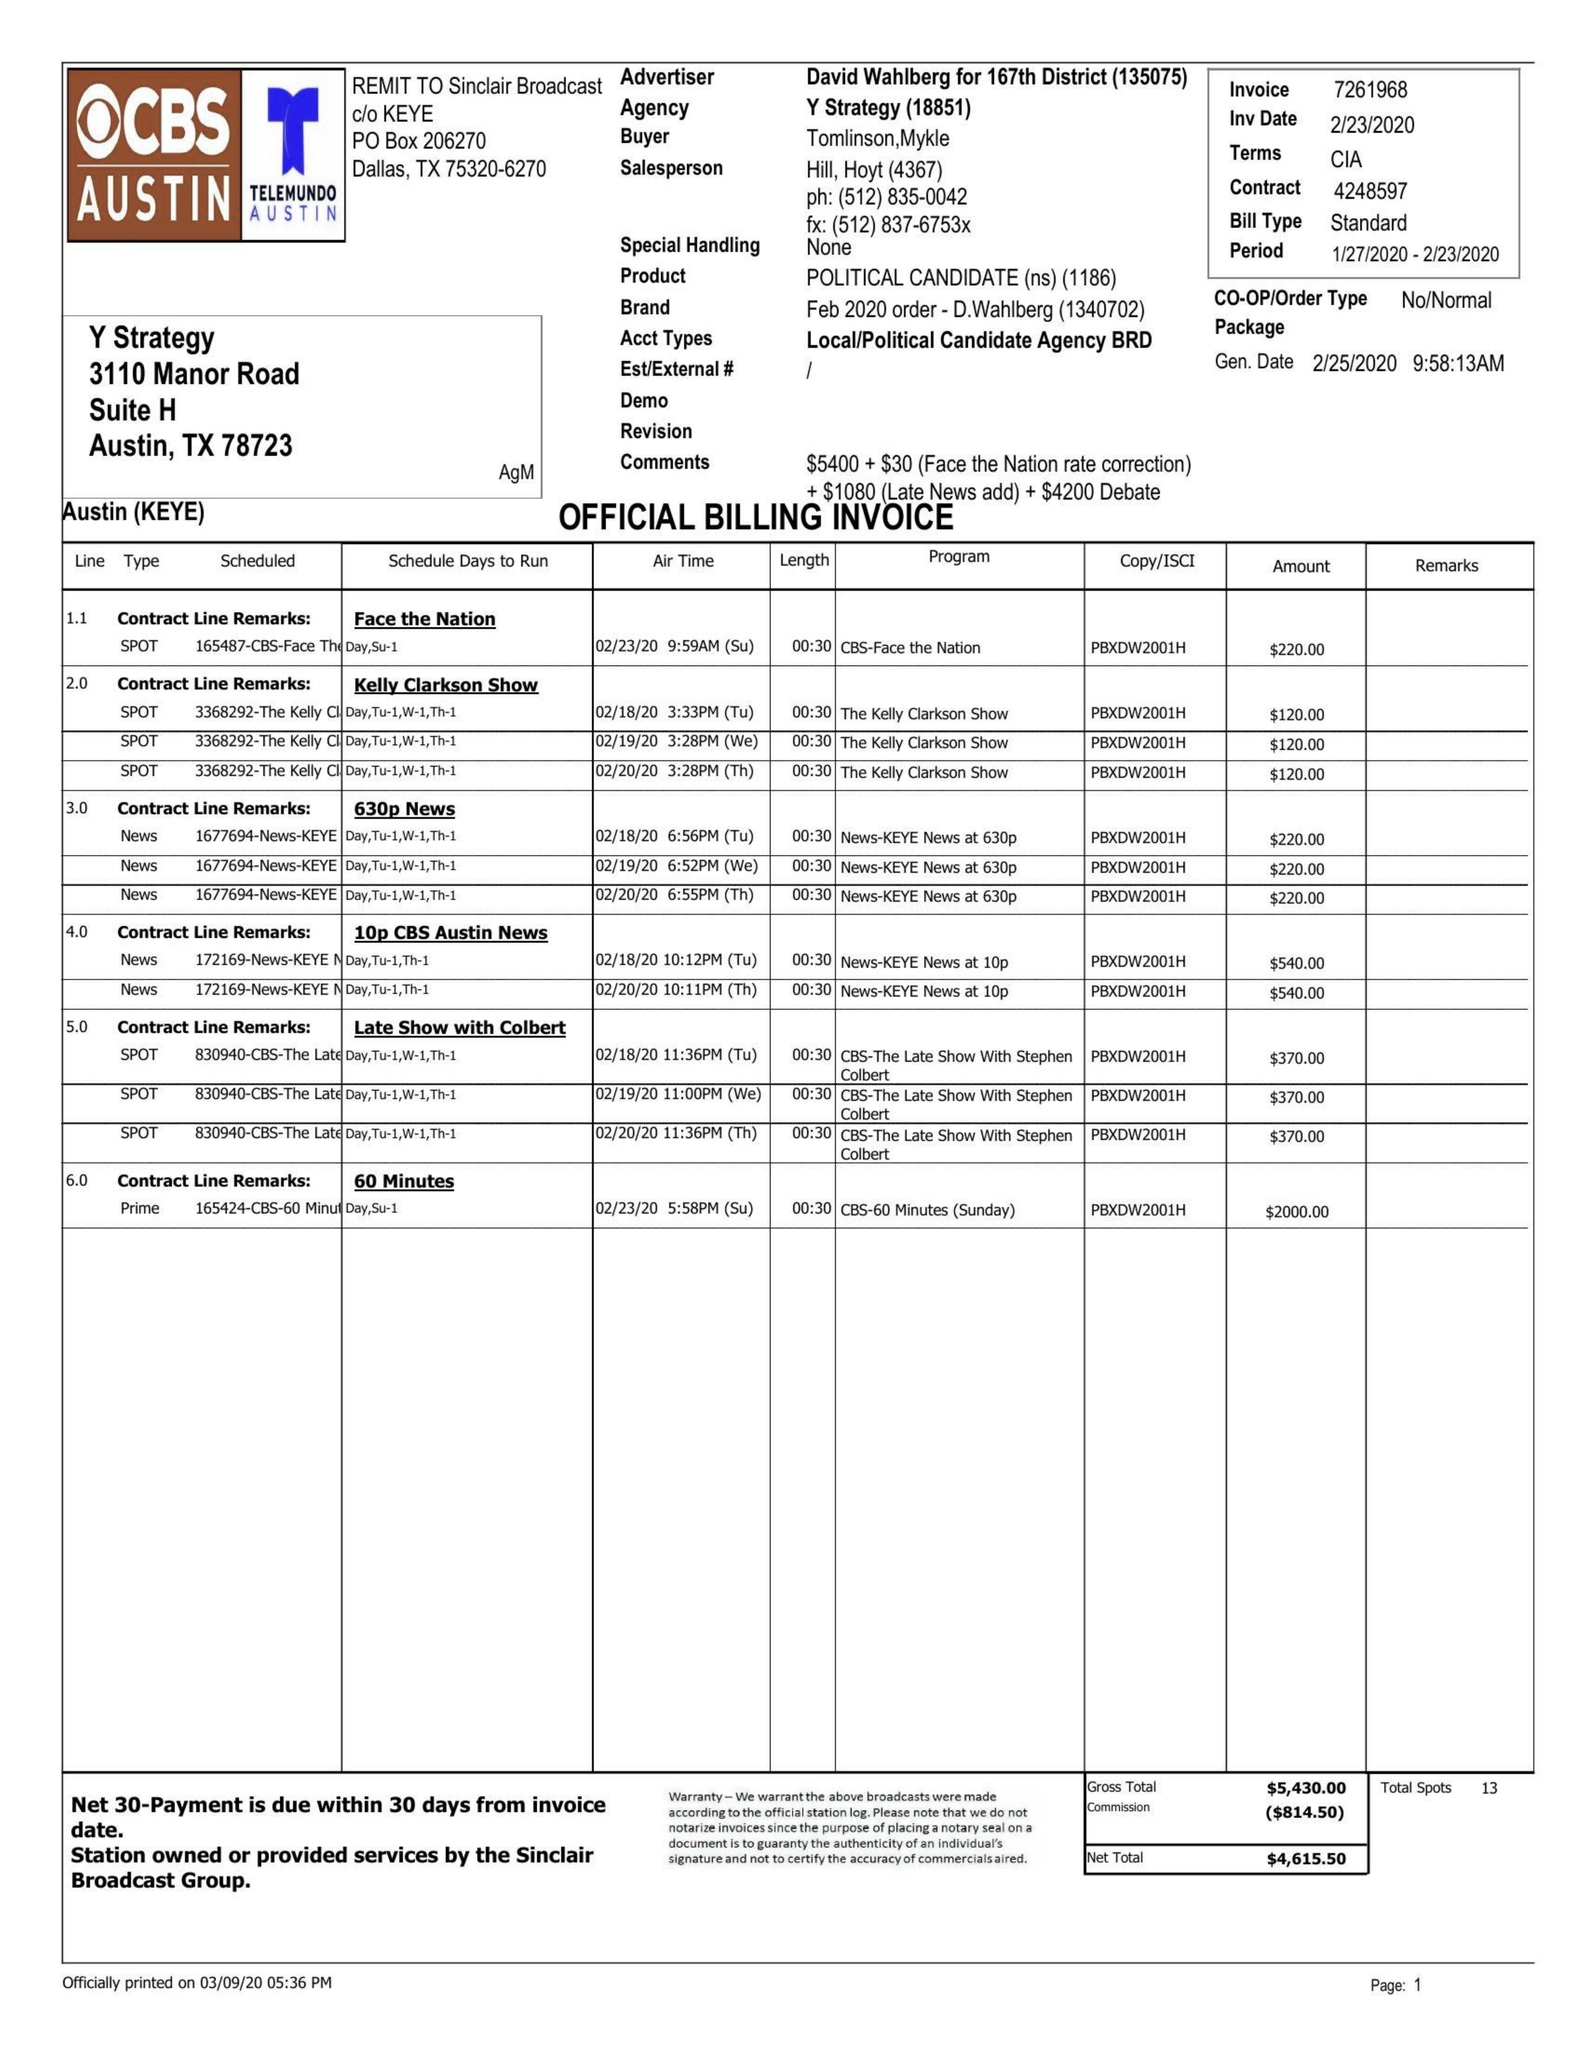What is the value for the contract_num?
Answer the question using a single word or phrase. 4248597 